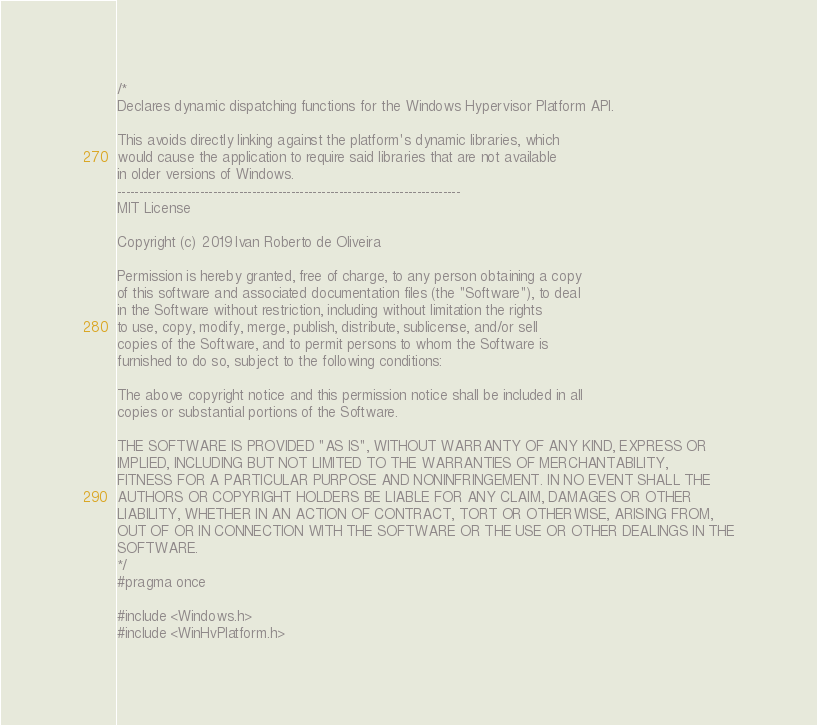Convert code to text. <code><loc_0><loc_0><loc_500><loc_500><_C++_>/*
Declares dynamic dispatching functions for the Windows Hypervisor Platform API.

This avoids directly linking against the platform's dynamic libraries, which
would cause the application to require said libraries that are not available
in older versions of Windows.
-------------------------------------------------------------------------------
MIT License

Copyright (c) 2019 Ivan Roberto de Oliveira

Permission is hereby granted, free of charge, to any person obtaining a copy
of this software and associated documentation files (the "Software"), to deal
in the Software without restriction, including without limitation the rights
to use, copy, modify, merge, publish, distribute, sublicense, and/or sell
copies of the Software, and to permit persons to whom the Software is
furnished to do so, subject to the following conditions:

The above copyright notice and this permission notice shall be included in all
copies or substantial portions of the Software.

THE SOFTWARE IS PROVIDED "AS IS", WITHOUT WARRANTY OF ANY KIND, EXPRESS OR
IMPLIED, INCLUDING BUT NOT LIMITED TO THE WARRANTIES OF MERCHANTABILITY,
FITNESS FOR A PARTICULAR PURPOSE AND NONINFRINGEMENT. IN NO EVENT SHALL THE
AUTHORS OR COPYRIGHT HOLDERS BE LIABLE FOR ANY CLAIM, DAMAGES OR OTHER
LIABILITY, WHETHER IN AN ACTION OF CONTRACT, TORT OR OTHERWISE, ARISING FROM,
OUT OF OR IN CONNECTION WITH THE SOFTWARE OR THE USE OR OTHER DEALINGS IN THE
SOFTWARE.
*/
#pragma once

#include <Windows.h>
#include <WinHvPlatform.h></code> 